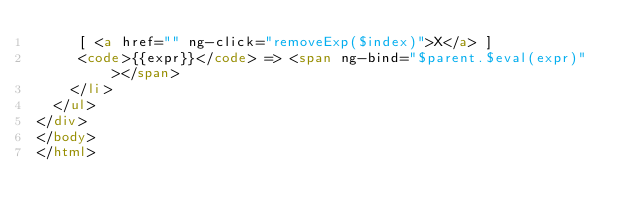Convert code to text. <code><loc_0><loc_0><loc_500><loc_500><_HTML_>     [ <a href="" ng-click="removeExp($index)">X</a> ]
     <code>{{expr}}</code> => <span ng-bind="$parent.$eval(expr)"></span>
    </li>
  </ul>
</div>
</body>
</html></code> 